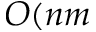Convert formula to latex. <formula><loc_0><loc_0><loc_500><loc_500>O ( n m</formula> 